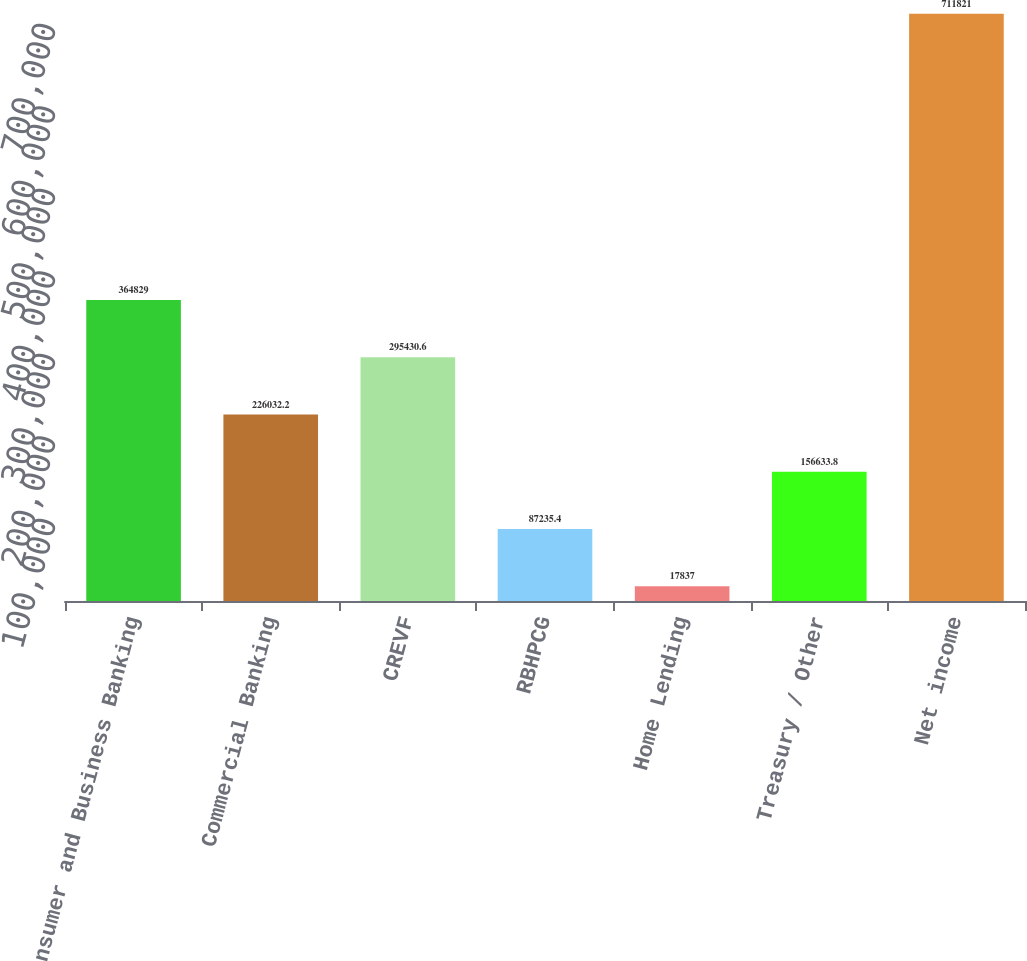<chart> <loc_0><loc_0><loc_500><loc_500><bar_chart><fcel>Consumer and Business Banking<fcel>Commercial Banking<fcel>CREVF<fcel>RBHPCG<fcel>Home Lending<fcel>Treasury / Other<fcel>Net income<nl><fcel>364829<fcel>226032<fcel>295431<fcel>87235.4<fcel>17837<fcel>156634<fcel>711821<nl></chart> 